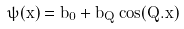Convert formula to latex. <formula><loc_0><loc_0><loc_500><loc_500>\bar { \psi } ( \vec { x } ) = b _ { 0 } + b _ { Q } \cos ( \vec { Q } . \vec { x } )</formula> 